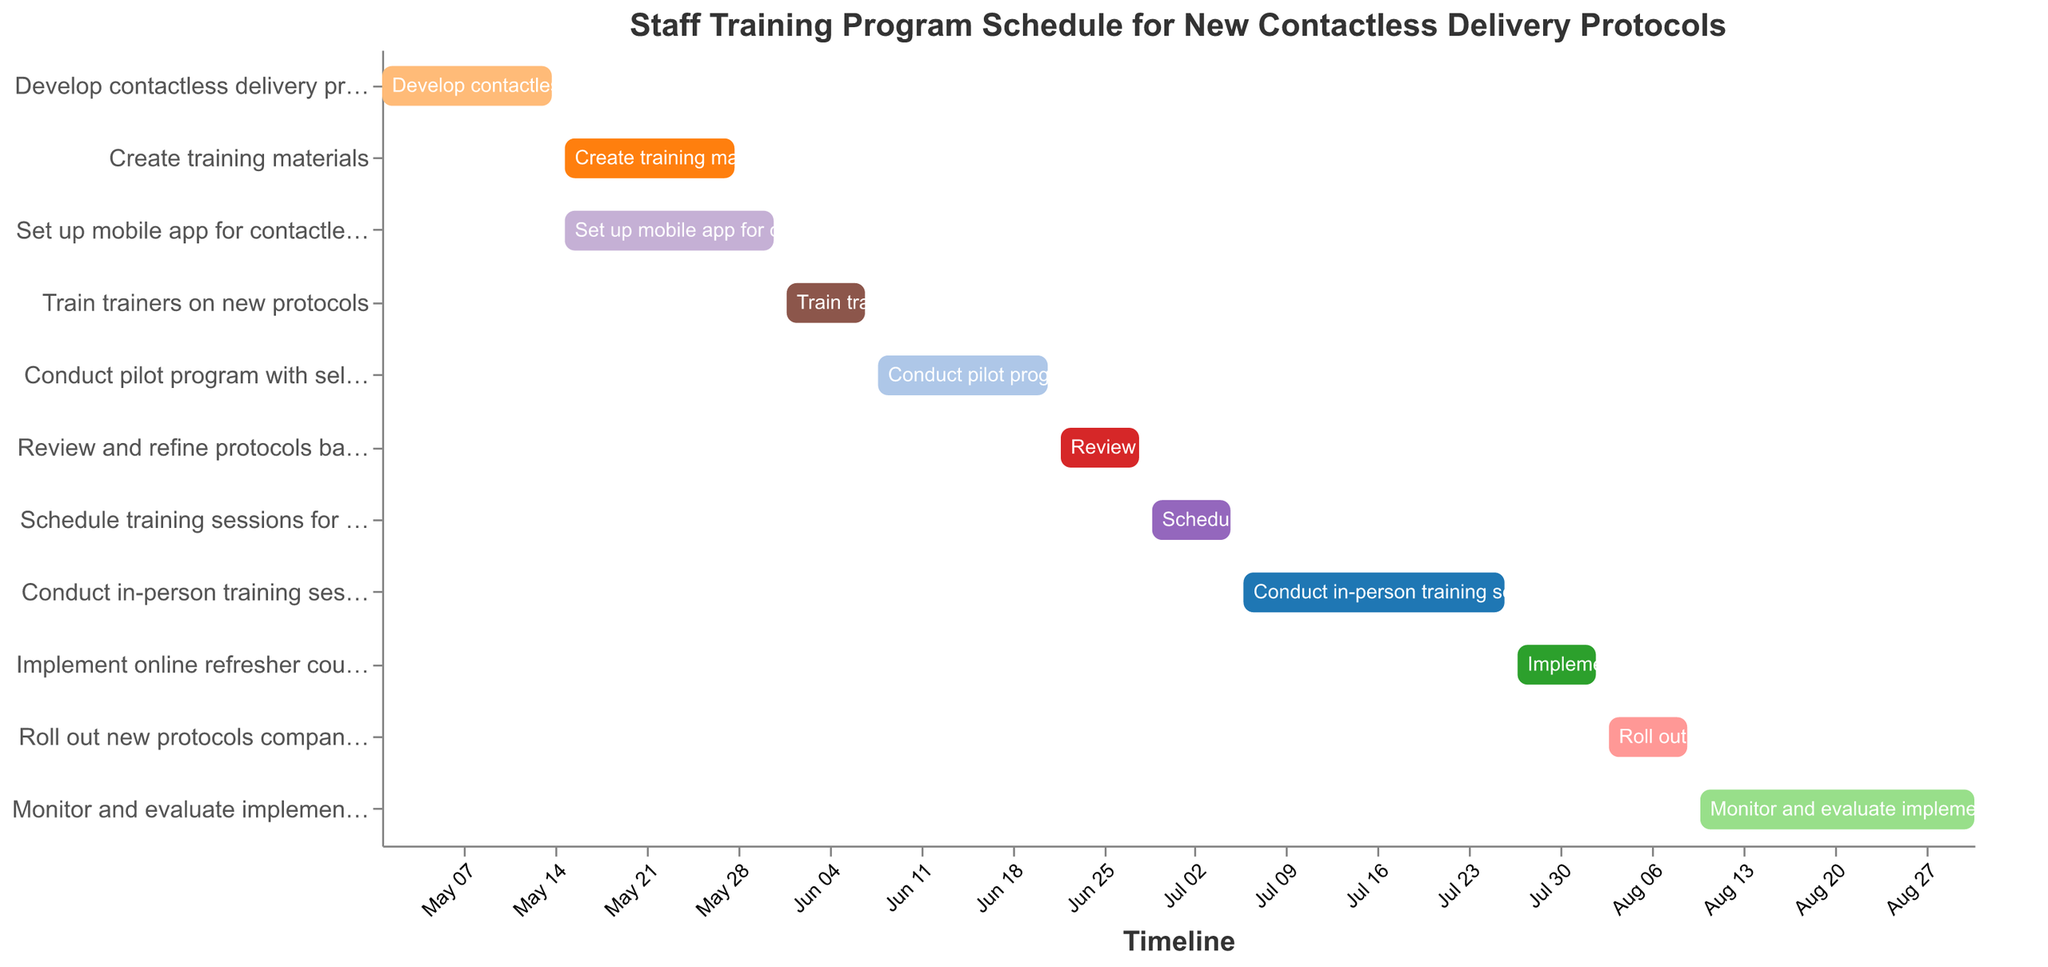What is the title of the Gantt chart? The title is prominently displayed at the top of the Gantt chart, describing the overall schedule being depicted.
Answer: Staff Training Program Schedule for New Contactless Delivery Protocols How many tasks are listed in the Gantt chart? Count the number of distinct tasks from top to bottom. Each task is a separate bar.
Answer: 11 Which task takes the longest time to complete, and how long is it? Compare the durations of all tasks and identify the maximum value.
Answer: Monitor and evaluate implementation, 22 days What tasks are scheduled to begin on May 15th? Look for tasks that have their start date marked as May 15th on the x-axis. There are bars positioned at this date.
Answer: Create training materials, Set up mobile app for contactless signatures How many tasks start in June? Identify the bars whose start dates fall within the month of June.
Answer: 4 Which tasks overlap in duration with the task "Conduct in-person training sessions"? Identify the period from July 6th to July 26th and see which other bars intersect this range.
Answer: Implement online refresher course, Roll out new protocols company-wide What is the total duration for "Develop contactless delivery protocol" and "Create training materials"? Sum the individual durations of both tasks.
Answer: 28 days When does the task "Schedule training sessions for all couriers" end? Look for the end date of the specified task.
Answer: July 5 Which tasks have a duration of exactly 7 days? Identify and list tasks with a duration of 7 days from the data provided.
Answer: Train trainers on new protocols, Review and refine protocols based on pilot, Schedule training sessions for all couriers, Implement online refresher course, Roll out new protocols company-wide When is the entire staff training program scheduled to be completed? Look for the end date of the last task in the Gantt chart.
Answer: August 31 